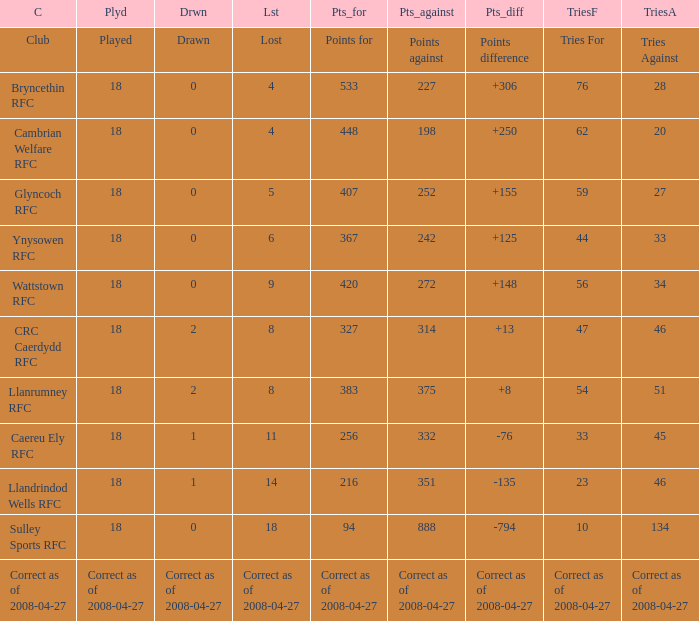What is the value of the item "Points" when the value of the item "Points against" is 272? 420.0. 